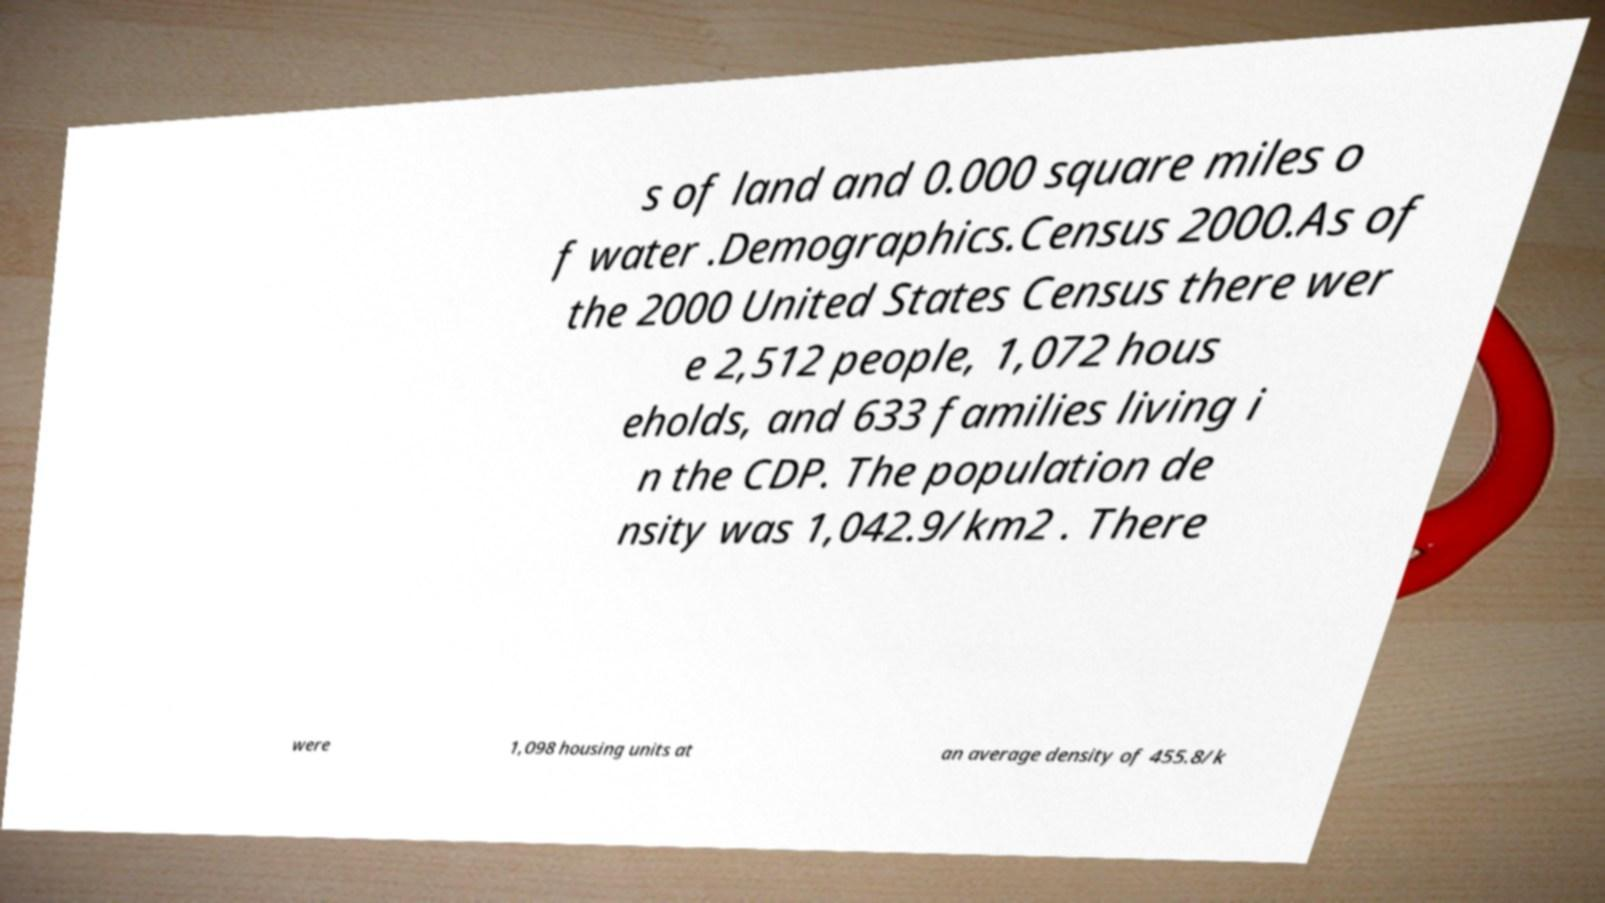I need the written content from this picture converted into text. Can you do that? s of land and 0.000 square miles o f water .Demographics.Census 2000.As of the 2000 United States Census there wer e 2,512 people, 1,072 hous eholds, and 633 families living i n the CDP. The population de nsity was 1,042.9/km2 . There were 1,098 housing units at an average density of 455.8/k 